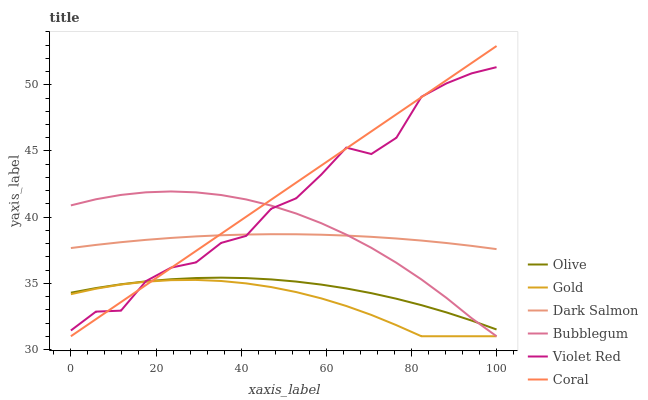Does Gold have the minimum area under the curve?
Answer yes or no. Yes. Does Coral have the maximum area under the curve?
Answer yes or no. Yes. Does Coral have the minimum area under the curve?
Answer yes or no. No. Does Gold have the maximum area under the curve?
Answer yes or no. No. Is Coral the smoothest?
Answer yes or no. Yes. Is Violet Red the roughest?
Answer yes or no. Yes. Is Gold the smoothest?
Answer yes or no. No. Is Gold the roughest?
Answer yes or no. No. Does Gold have the lowest value?
Answer yes or no. Yes. Does Dark Salmon have the lowest value?
Answer yes or no. No. Does Coral have the highest value?
Answer yes or no. Yes. Does Gold have the highest value?
Answer yes or no. No. Is Olive less than Dark Salmon?
Answer yes or no. Yes. Is Olive greater than Gold?
Answer yes or no. Yes. Does Bubblegum intersect Dark Salmon?
Answer yes or no. Yes. Is Bubblegum less than Dark Salmon?
Answer yes or no. No. Is Bubblegum greater than Dark Salmon?
Answer yes or no. No. Does Olive intersect Dark Salmon?
Answer yes or no. No. 